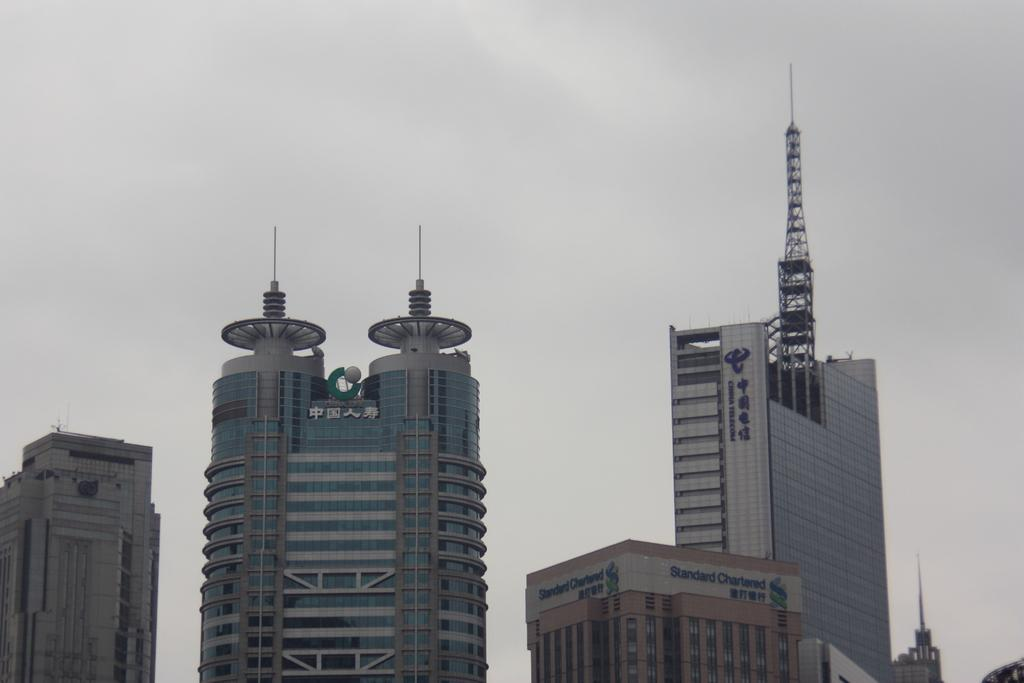What structures are located in the middle of the picture? There are buildings in the middle of the picture. What can be seen in the background of the picture? The sky is visible in the background of the picture. What type of pain is being experienced by the tree in the image? There is no tree present in the image, so it is not possible to determine if any pain is being experienced. 